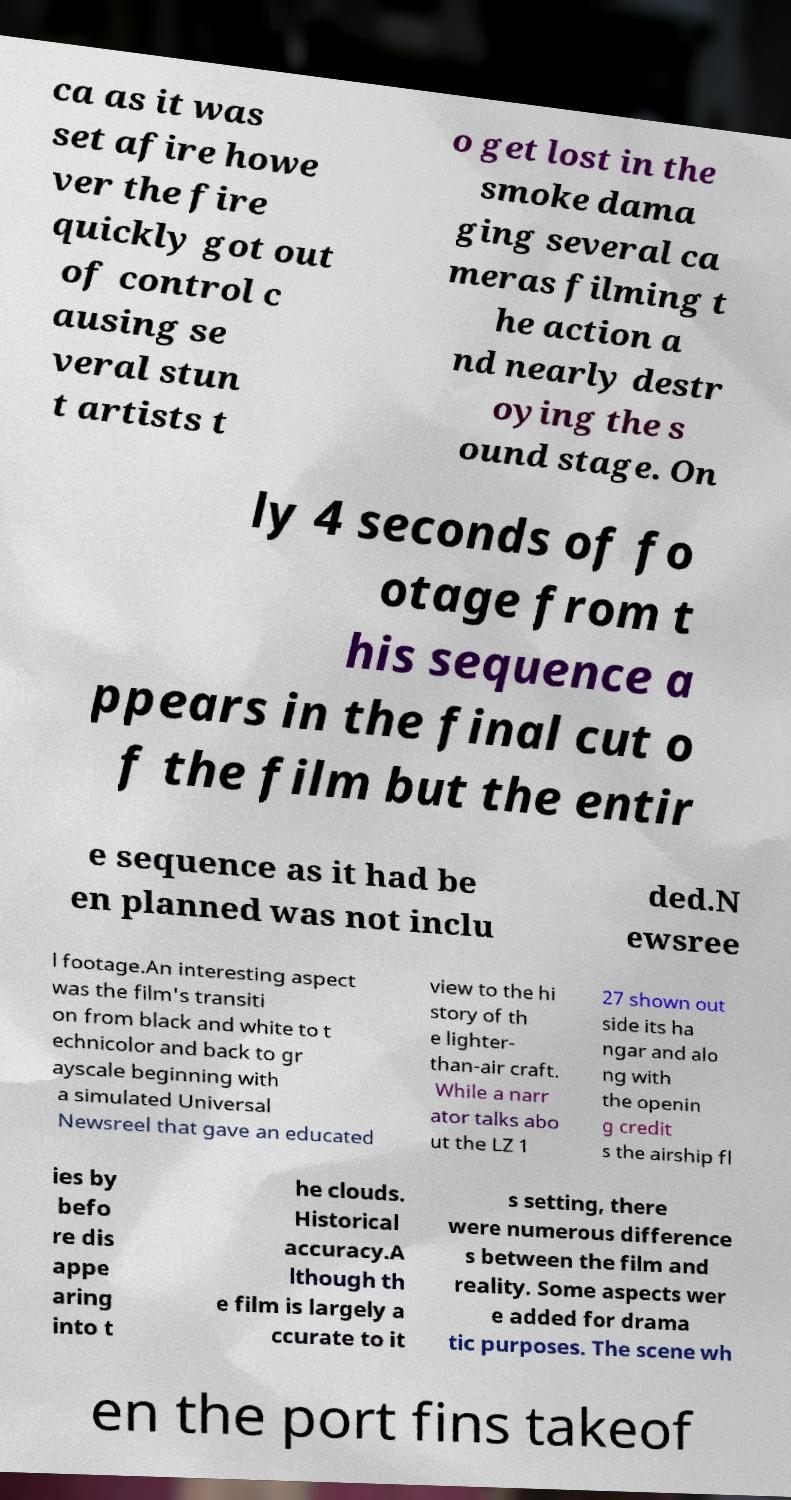For documentation purposes, I need the text within this image transcribed. Could you provide that? ca as it was set afire howe ver the fire quickly got out of control c ausing se veral stun t artists t o get lost in the smoke dama ging several ca meras filming t he action a nd nearly destr oying the s ound stage. On ly 4 seconds of fo otage from t his sequence a ppears in the final cut o f the film but the entir e sequence as it had be en planned was not inclu ded.N ewsree l footage.An interesting aspect was the film's transiti on from black and white to t echnicolor and back to gr ayscale beginning with a simulated Universal Newsreel that gave an educated view to the hi story of th e lighter- than-air craft. While a narr ator talks abo ut the LZ 1 27 shown out side its ha ngar and alo ng with the openin g credit s the airship fl ies by befo re dis appe aring into t he clouds. Historical accuracy.A lthough th e film is largely a ccurate to it s setting, there were numerous difference s between the film and reality. Some aspects wer e added for drama tic purposes. The scene wh en the port fins takeof 